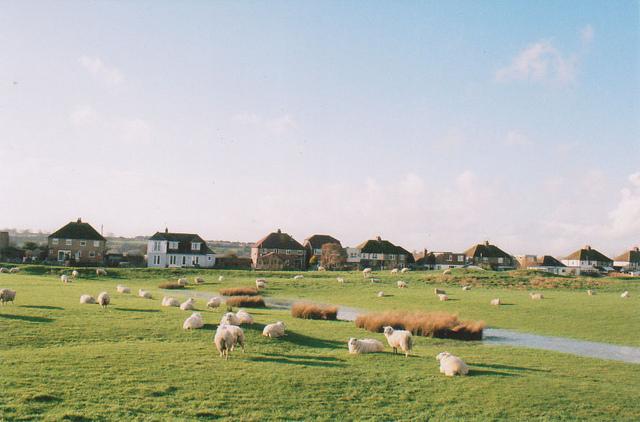What animals are those?
Concise answer only. Sheep. How is the weather?
Quick response, please. Sunny. What is in the background?
Write a very short answer. Houses. Have the sheep been recently sheared?
Concise answer only. No. 